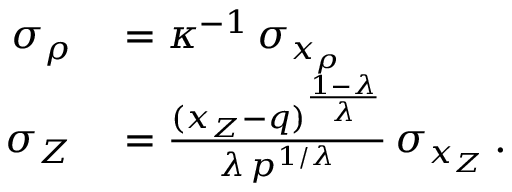Convert formula to latex. <formula><loc_0><loc_0><loc_500><loc_500>\begin{array} { r l } { \sigma _ { \rho } } & = \kappa ^ { - 1 } \, \sigma _ { x _ { \rho } } } \\ { \sigma _ { Z } } & = \frac { ( x _ { Z } - q ) ^ { \frac { 1 - \lambda } { \lambda } } } { \lambda \, p ^ { 1 / \lambda } } \, \sigma _ { x _ { Z } } \, . } \end{array}</formula> 